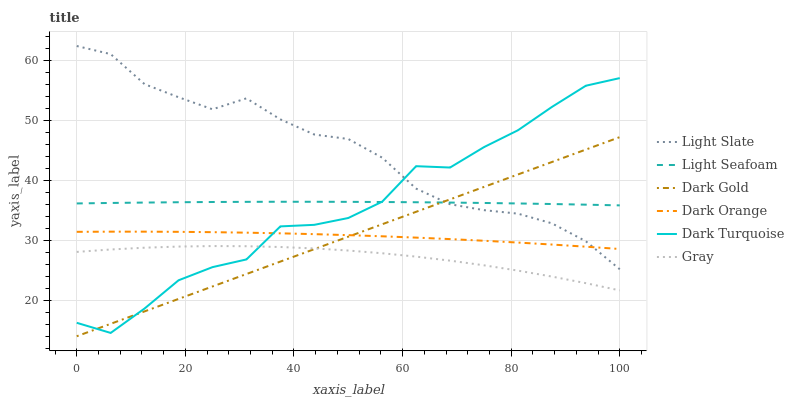Does Gray have the minimum area under the curve?
Answer yes or no. Yes. Does Light Slate have the maximum area under the curve?
Answer yes or no. Yes. Does Light Slate have the minimum area under the curve?
Answer yes or no. No. Does Gray have the maximum area under the curve?
Answer yes or no. No. Is Dark Gold the smoothest?
Answer yes or no. Yes. Is Dark Turquoise the roughest?
Answer yes or no. Yes. Is Gray the smoothest?
Answer yes or no. No. Is Gray the roughest?
Answer yes or no. No. Does Gray have the lowest value?
Answer yes or no. No. Does Light Slate have the highest value?
Answer yes or no. Yes. Does Gray have the highest value?
Answer yes or no. No. Is Gray less than Light Slate?
Answer yes or no. Yes. Is Light Seafoam greater than Dark Orange?
Answer yes or no. Yes. Does Dark Turquoise intersect Light Slate?
Answer yes or no. Yes. Is Dark Turquoise less than Light Slate?
Answer yes or no. No. Is Dark Turquoise greater than Light Slate?
Answer yes or no. No. Does Gray intersect Light Slate?
Answer yes or no. No. 